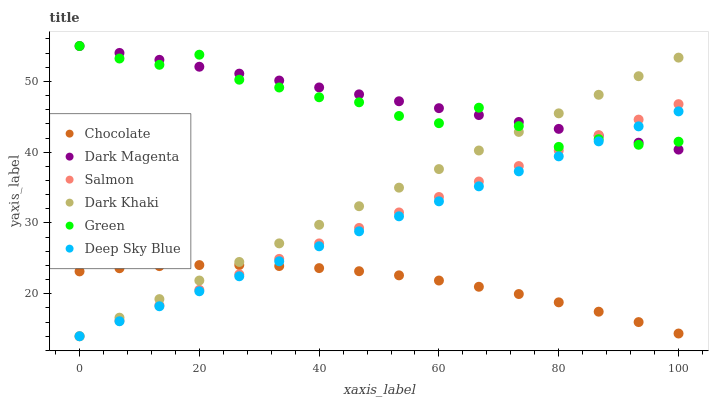Does Chocolate have the minimum area under the curve?
Answer yes or no. Yes. Does Dark Magenta have the maximum area under the curve?
Answer yes or no. Yes. Does Salmon have the minimum area under the curve?
Answer yes or no. No. Does Salmon have the maximum area under the curve?
Answer yes or no. No. Is Dark Magenta the smoothest?
Answer yes or no. Yes. Is Green the roughest?
Answer yes or no. Yes. Is Salmon the smoothest?
Answer yes or no. No. Is Salmon the roughest?
Answer yes or no. No. Does Salmon have the lowest value?
Answer yes or no. Yes. Does Chocolate have the lowest value?
Answer yes or no. No. Does Green have the highest value?
Answer yes or no. Yes. Does Salmon have the highest value?
Answer yes or no. No. Is Chocolate less than Dark Magenta?
Answer yes or no. Yes. Is Dark Magenta greater than Chocolate?
Answer yes or no. Yes. Does Salmon intersect Dark Khaki?
Answer yes or no. Yes. Is Salmon less than Dark Khaki?
Answer yes or no. No. Is Salmon greater than Dark Khaki?
Answer yes or no. No. Does Chocolate intersect Dark Magenta?
Answer yes or no. No. 